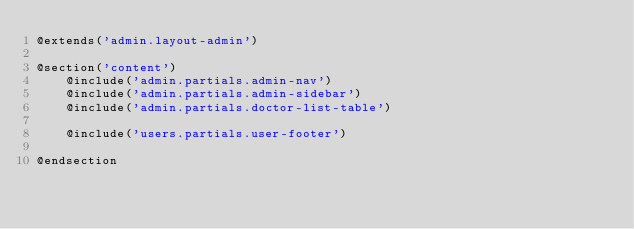<code> <loc_0><loc_0><loc_500><loc_500><_PHP_>@extends('admin.layout-admin')

@section('content')
    @include('admin.partials.admin-nav')
    @include('admin.partials.admin-sidebar')
    @include('admin.partials.doctor-list-table')

    @include('users.partials.user-footer')

@endsection</code> 